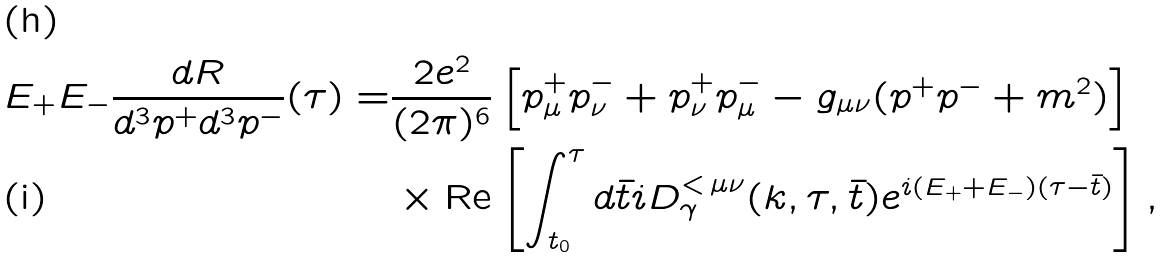<formula> <loc_0><loc_0><loc_500><loc_500>E _ { + } E _ { - } \frac { d R } { d ^ { 3 } p ^ { + } d ^ { 3 } p ^ { - } } ( \tau ) = & \frac { 2 e ^ { 2 } } { ( 2 \pi ) ^ { 6 } } \left [ p _ { \mu } ^ { + } p _ { \nu } ^ { - } + p _ { \nu } ^ { + } p _ { \mu } ^ { - } - g _ { \mu \nu } ( p ^ { + } p ^ { - } + m ^ { 2 } ) \right ] \\ & \times \text {Re} \left [ \int _ { t _ { 0 } } ^ { \tau } d \bar { t } i D _ { \gamma } ^ { < \, \mu \nu } ( k , \tau , \bar { t } ) e ^ { i ( E _ { + } + E _ { - } ) ( \tau - \bar { t } ) } \right ] \text {,}</formula> 